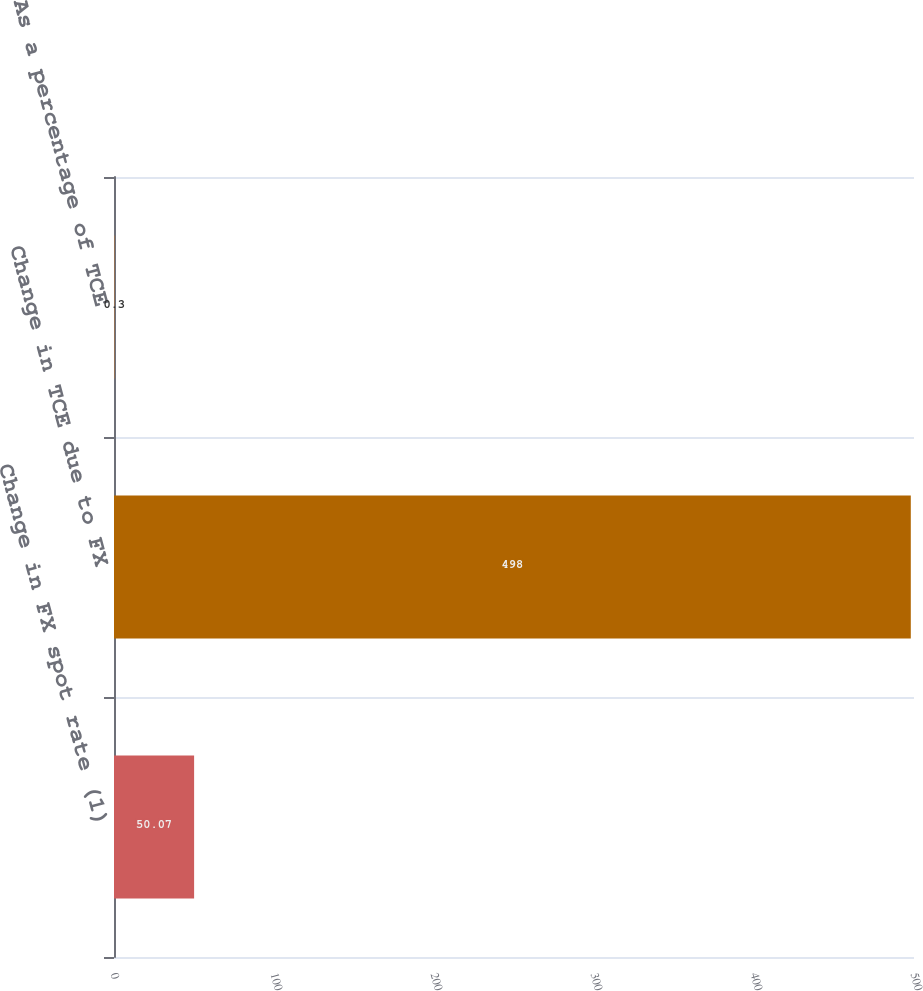Convert chart. <chart><loc_0><loc_0><loc_500><loc_500><bar_chart><fcel>Change in FX spot rate (1)<fcel>Change in TCE due to FX<fcel>As a percentage of TCE<nl><fcel>50.07<fcel>498<fcel>0.3<nl></chart> 